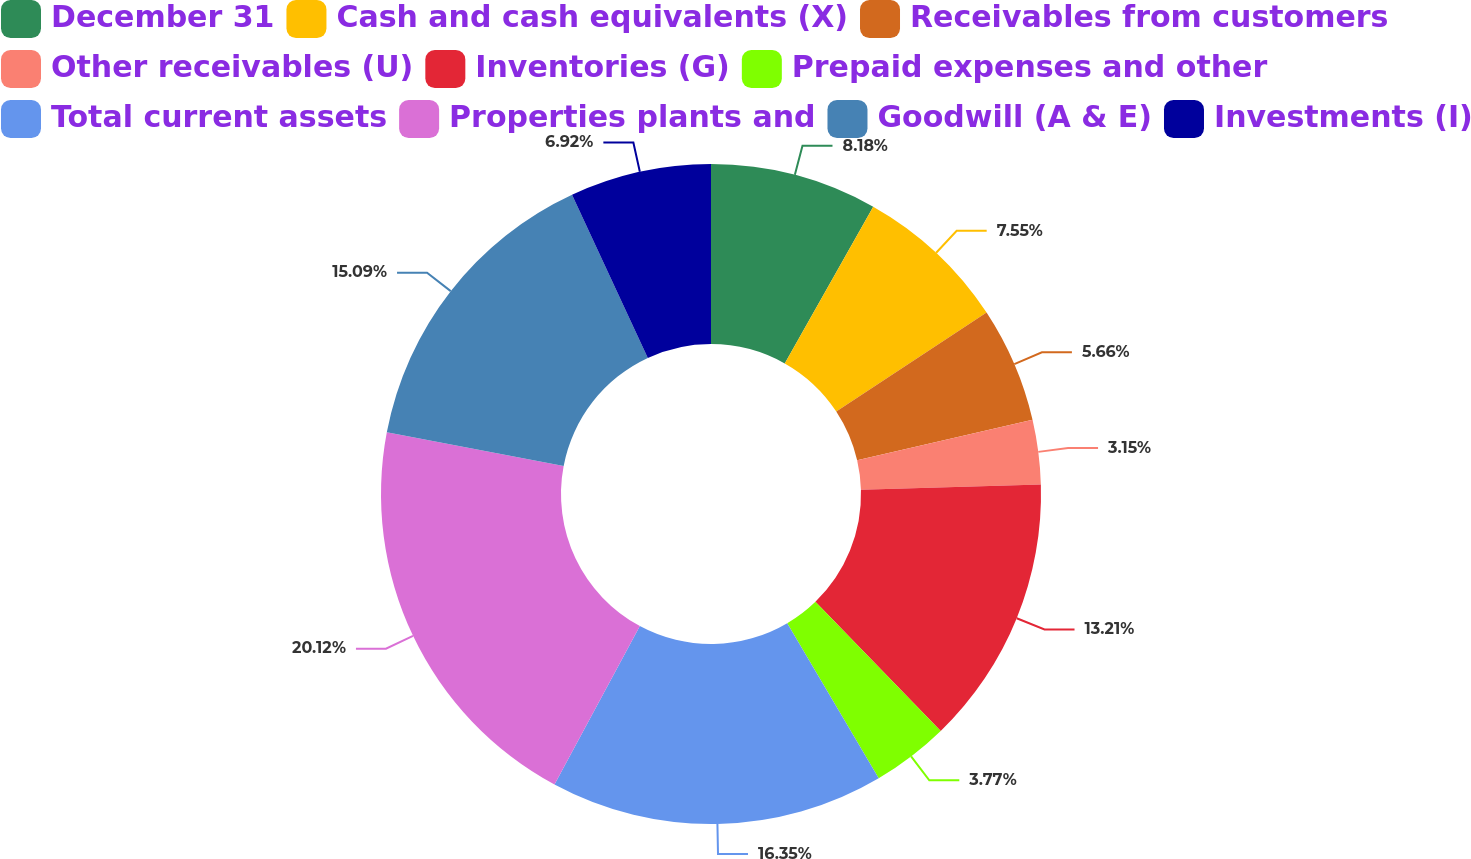Convert chart to OTSL. <chart><loc_0><loc_0><loc_500><loc_500><pie_chart><fcel>December 31<fcel>Cash and cash equivalents (X)<fcel>Receivables from customers<fcel>Other receivables (U)<fcel>Inventories (G)<fcel>Prepaid expenses and other<fcel>Total current assets<fcel>Properties plants and<fcel>Goodwill (A & E)<fcel>Investments (I)<nl><fcel>8.18%<fcel>7.55%<fcel>5.66%<fcel>3.15%<fcel>13.21%<fcel>3.77%<fcel>16.35%<fcel>20.13%<fcel>15.09%<fcel>6.92%<nl></chart> 